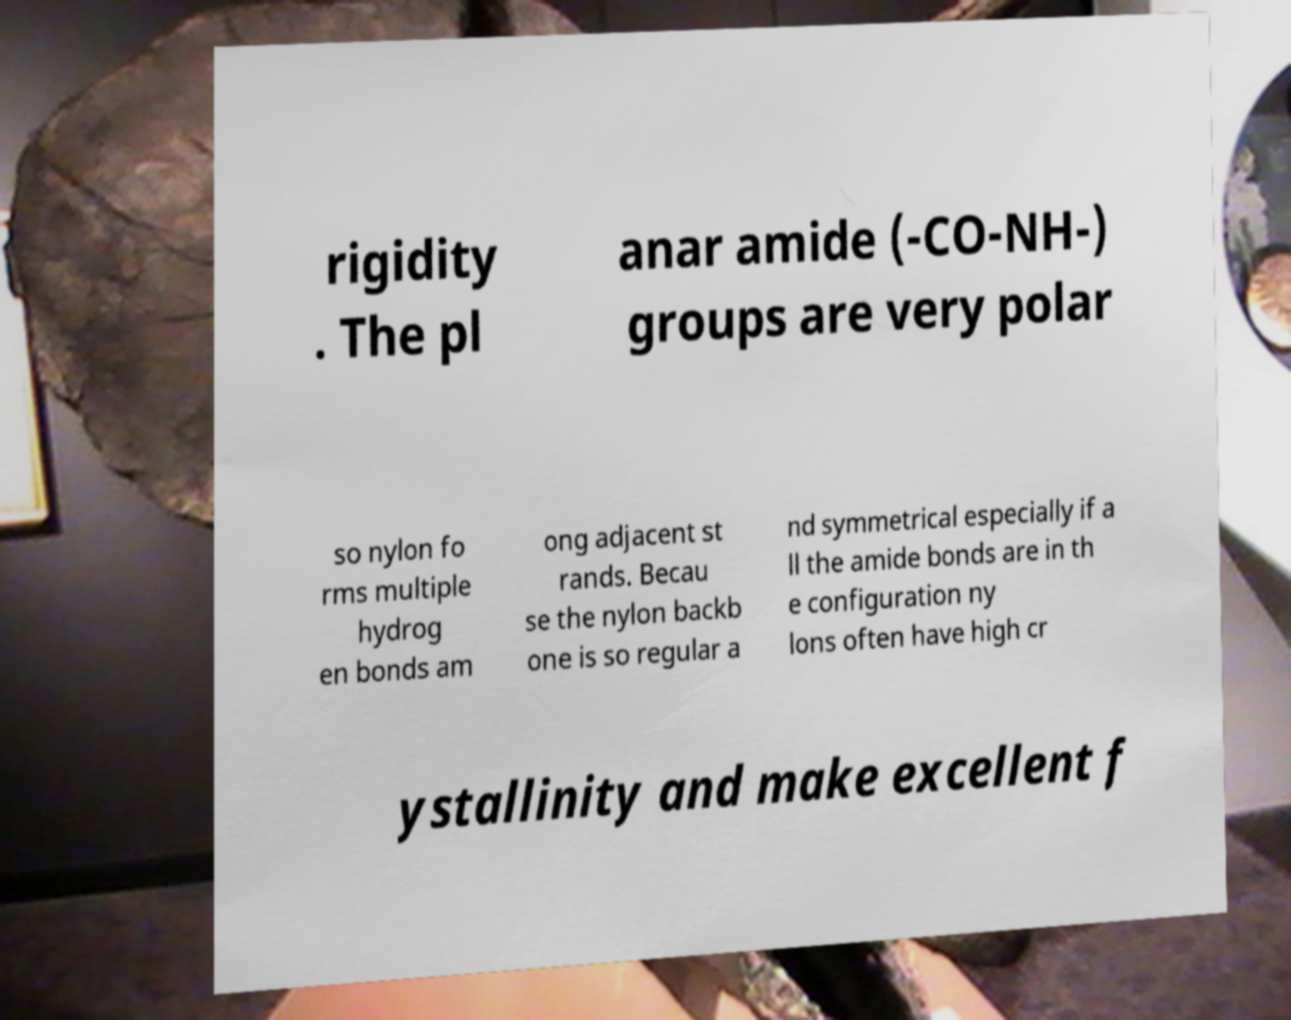Could you extract and type out the text from this image? rigidity . The pl anar amide (-CO-NH-) groups are very polar so nylon fo rms multiple hydrog en bonds am ong adjacent st rands. Becau se the nylon backb one is so regular a nd symmetrical especially if a ll the amide bonds are in th e configuration ny lons often have high cr ystallinity and make excellent f 